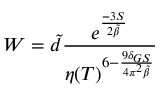<formula> <loc_0><loc_0><loc_500><loc_500>W = \tilde { d } \frac { e ^ { \frac { - 3 S } { 2 \tilde { \beta } } } } { \eta ( T ) ^ { 6 - \frac { 9 \delta _ { G S } } { 4 \pi ^ { 2 } \tilde { \beta } } } }</formula> 